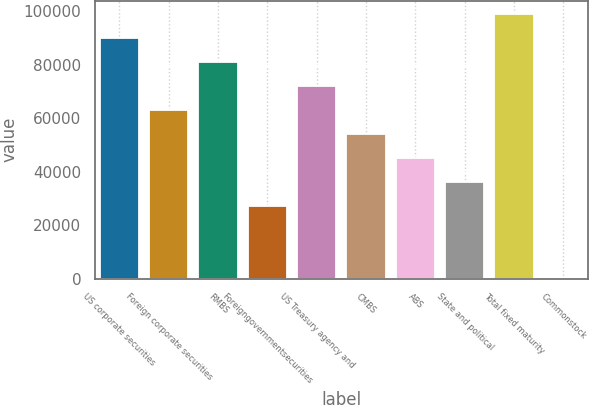Convert chart. <chart><loc_0><loc_0><loc_500><loc_500><bar_chart><fcel>US corporate securities<fcel>Foreign corporate securities<fcel>RMBS<fcel>Foreigngovernmentsecurities<fcel>US Treasury agency and<fcel>CMBS<fcel>ABS<fcel>State and political<fcel>Total fixed maturity<fcel>Commonstock<nl><fcel>90087<fcel>63081.9<fcel>81085.3<fcel>27075.1<fcel>72083.6<fcel>54080.2<fcel>45078.5<fcel>36076.8<fcel>99088.7<fcel>70<nl></chart> 